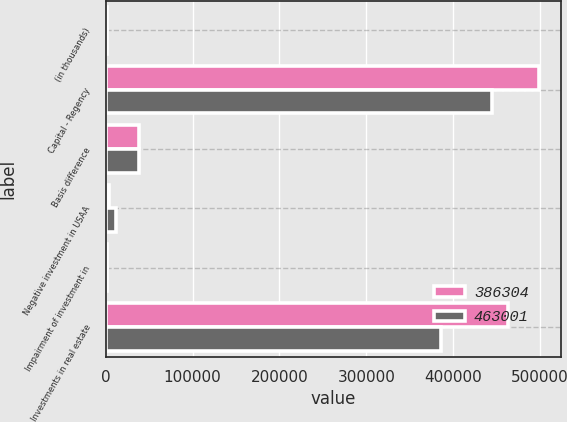Convert chart to OTSL. <chart><loc_0><loc_0><loc_500><loc_500><stacked_bar_chart><ecel><fcel>(in thousands)<fcel>Capital - Regency<fcel>Basis difference<fcel>Negative investment in USAA<fcel>Impairment of investment in<fcel>Investments in real estate<nl><fcel>386304<fcel>2018<fcel>498852<fcel>38064<fcel>3513<fcel>1300<fcel>463001<nl><fcel>463001<fcel>2017<fcel>445068<fcel>37852<fcel>11290<fcel>1300<fcel>386304<nl></chart> 